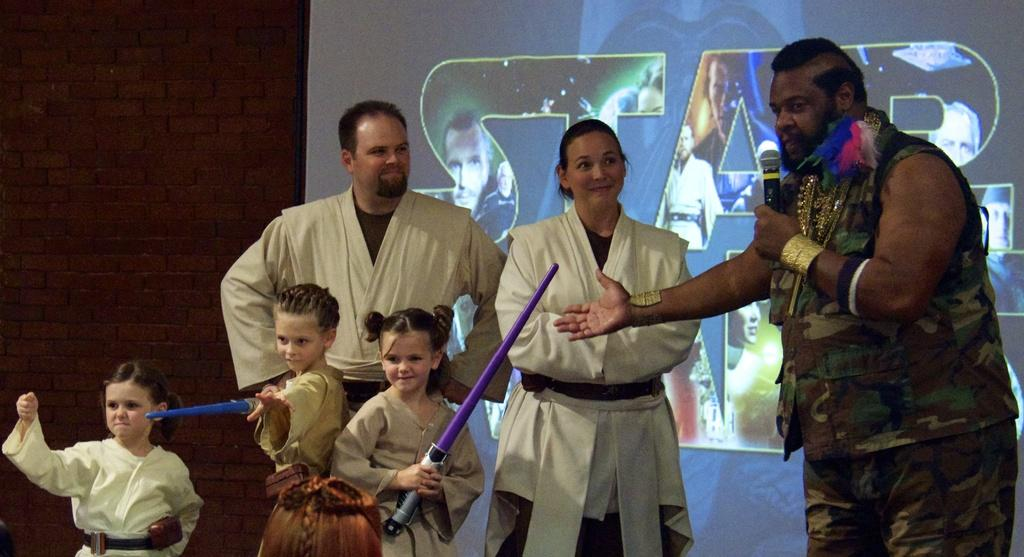How many people are present in the image? There are people in the image, but the exact number is not specified. What are the girls holding in the image? Two girls are holding objects in the image. What is the man holding in the image? The man is holding a mic in the image. What can be seen in the background of the image? There is a wall and a screen in the background of the image. What type of skin condition is visible on the people in the image? There is no mention of any skin condition in the image, so it cannot be determined from the facts provided. 